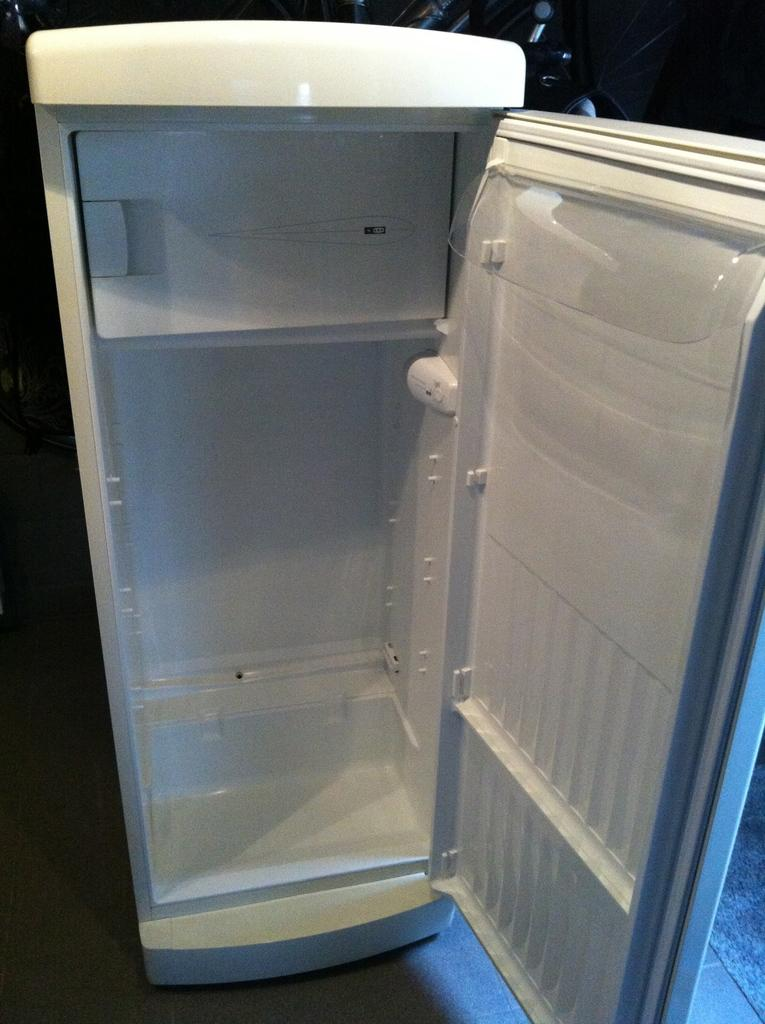What type of appliance can be seen in the image? There is a refrigerator in the image. Where is the refrigerator located? The refrigerator is on the floor. What is the position of the refrigerator's door? The refrigerator's door is opened. What type of cub can be seen playing with the refrigerator door in the image? There is no cub present in the image, and therefore no such activity can be observed. 